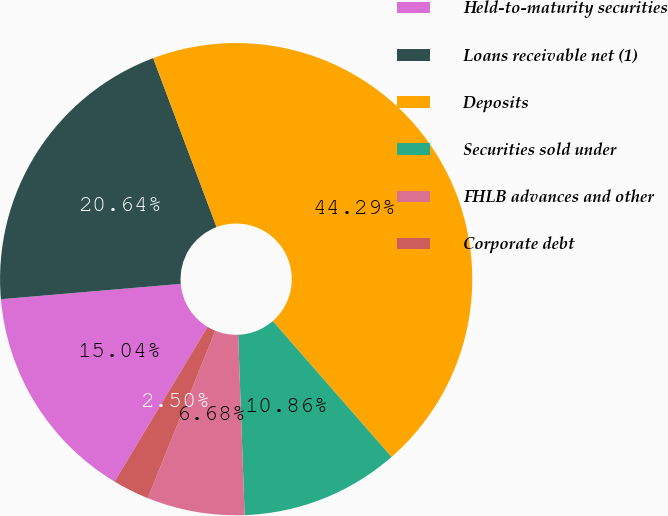<chart> <loc_0><loc_0><loc_500><loc_500><pie_chart><fcel>Held-to-maturity securities<fcel>Loans receivable net (1)<fcel>Deposits<fcel>Securities sold under<fcel>FHLB advances and other<fcel>Corporate debt<nl><fcel>15.04%<fcel>20.64%<fcel>44.29%<fcel>10.86%<fcel>6.68%<fcel>2.5%<nl></chart> 